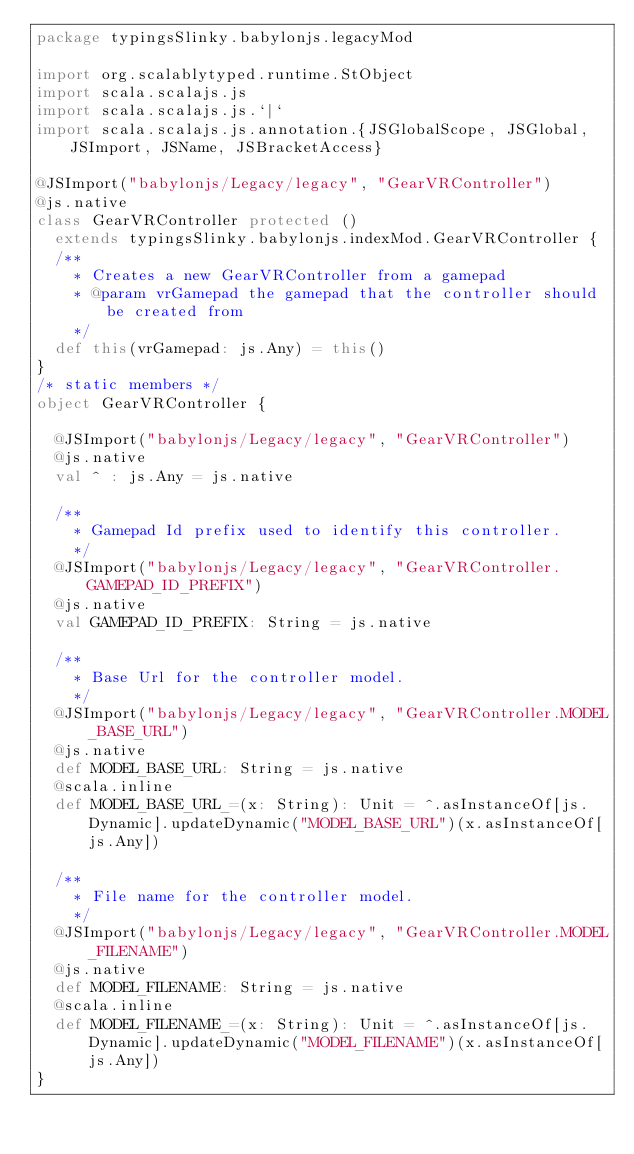<code> <loc_0><loc_0><loc_500><loc_500><_Scala_>package typingsSlinky.babylonjs.legacyMod

import org.scalablytyped.runtime.StObject
import scala.scalajs.js
import scala.scalajs.js.`|`
import scala.scalajs.js.annotation.{JSGlobalScope, JSGlobal, JSImport, JSName, JSBracketAccess}

@JSImport("babylonjs/Legacy/legacy", "GearVRController")
@js.native
class GearVRController protected ()
  extends typingsSlinky.babylonjs.indexMod.GearVRController {
  /**
    * Creates a new GearVRController from a gamepad
    * @param vrGamepad the gamepad that the controller should be created from
    */
  def this(vrGamepad: js.Any) = this()
}
/* static members */
object GearVRController {
  
  @JSImport("babylonjs/Legacy/legacy", "GearVRController")
  @js.native
  val ^ : js.Any = js.native
  
  /**
    * Gamepad Id prefix used to identify this controller.
    */
  @JSImport("babylonjs/Legacy/legacy", "GearVRController.GAMEPAD_ID_PREFIX")
  @js.native
  val GAMEPAD_ID_PREFIX: String = js.native
  
  /**
    * Base Url for the controller model.
    */
  @JSImport("babylonjs/Legacy/legacy", "GearVRController.MODEL_BASE_URL")
  @js.native
  def MODEL_BASE_URL: String = js.native
  @scala.inline
  def MODEL_BASE_URL_=(x: String): Unit = ^.asInstanceOf[js.Dynamic].updateDynamic("MODEL_BASE_URL")(x.asInstanceOf[js.Any])
  
  /**
    * File name for the controller model.
    */
  @JSImport("babylonjs/Legacy/legacy", "GearVRController.MODEL_FILENAME")
  @js.native
  def MODEL_FILENAME: String = js.native
  @scala.inline
  def MODEL_FILENAME_=(x: String): Unit = ^.asInstanceOf[js.Dynamic].updateDynamic("MODEL_FILENAME")(x.asInstanceOf[js.Any])
}
</code> 